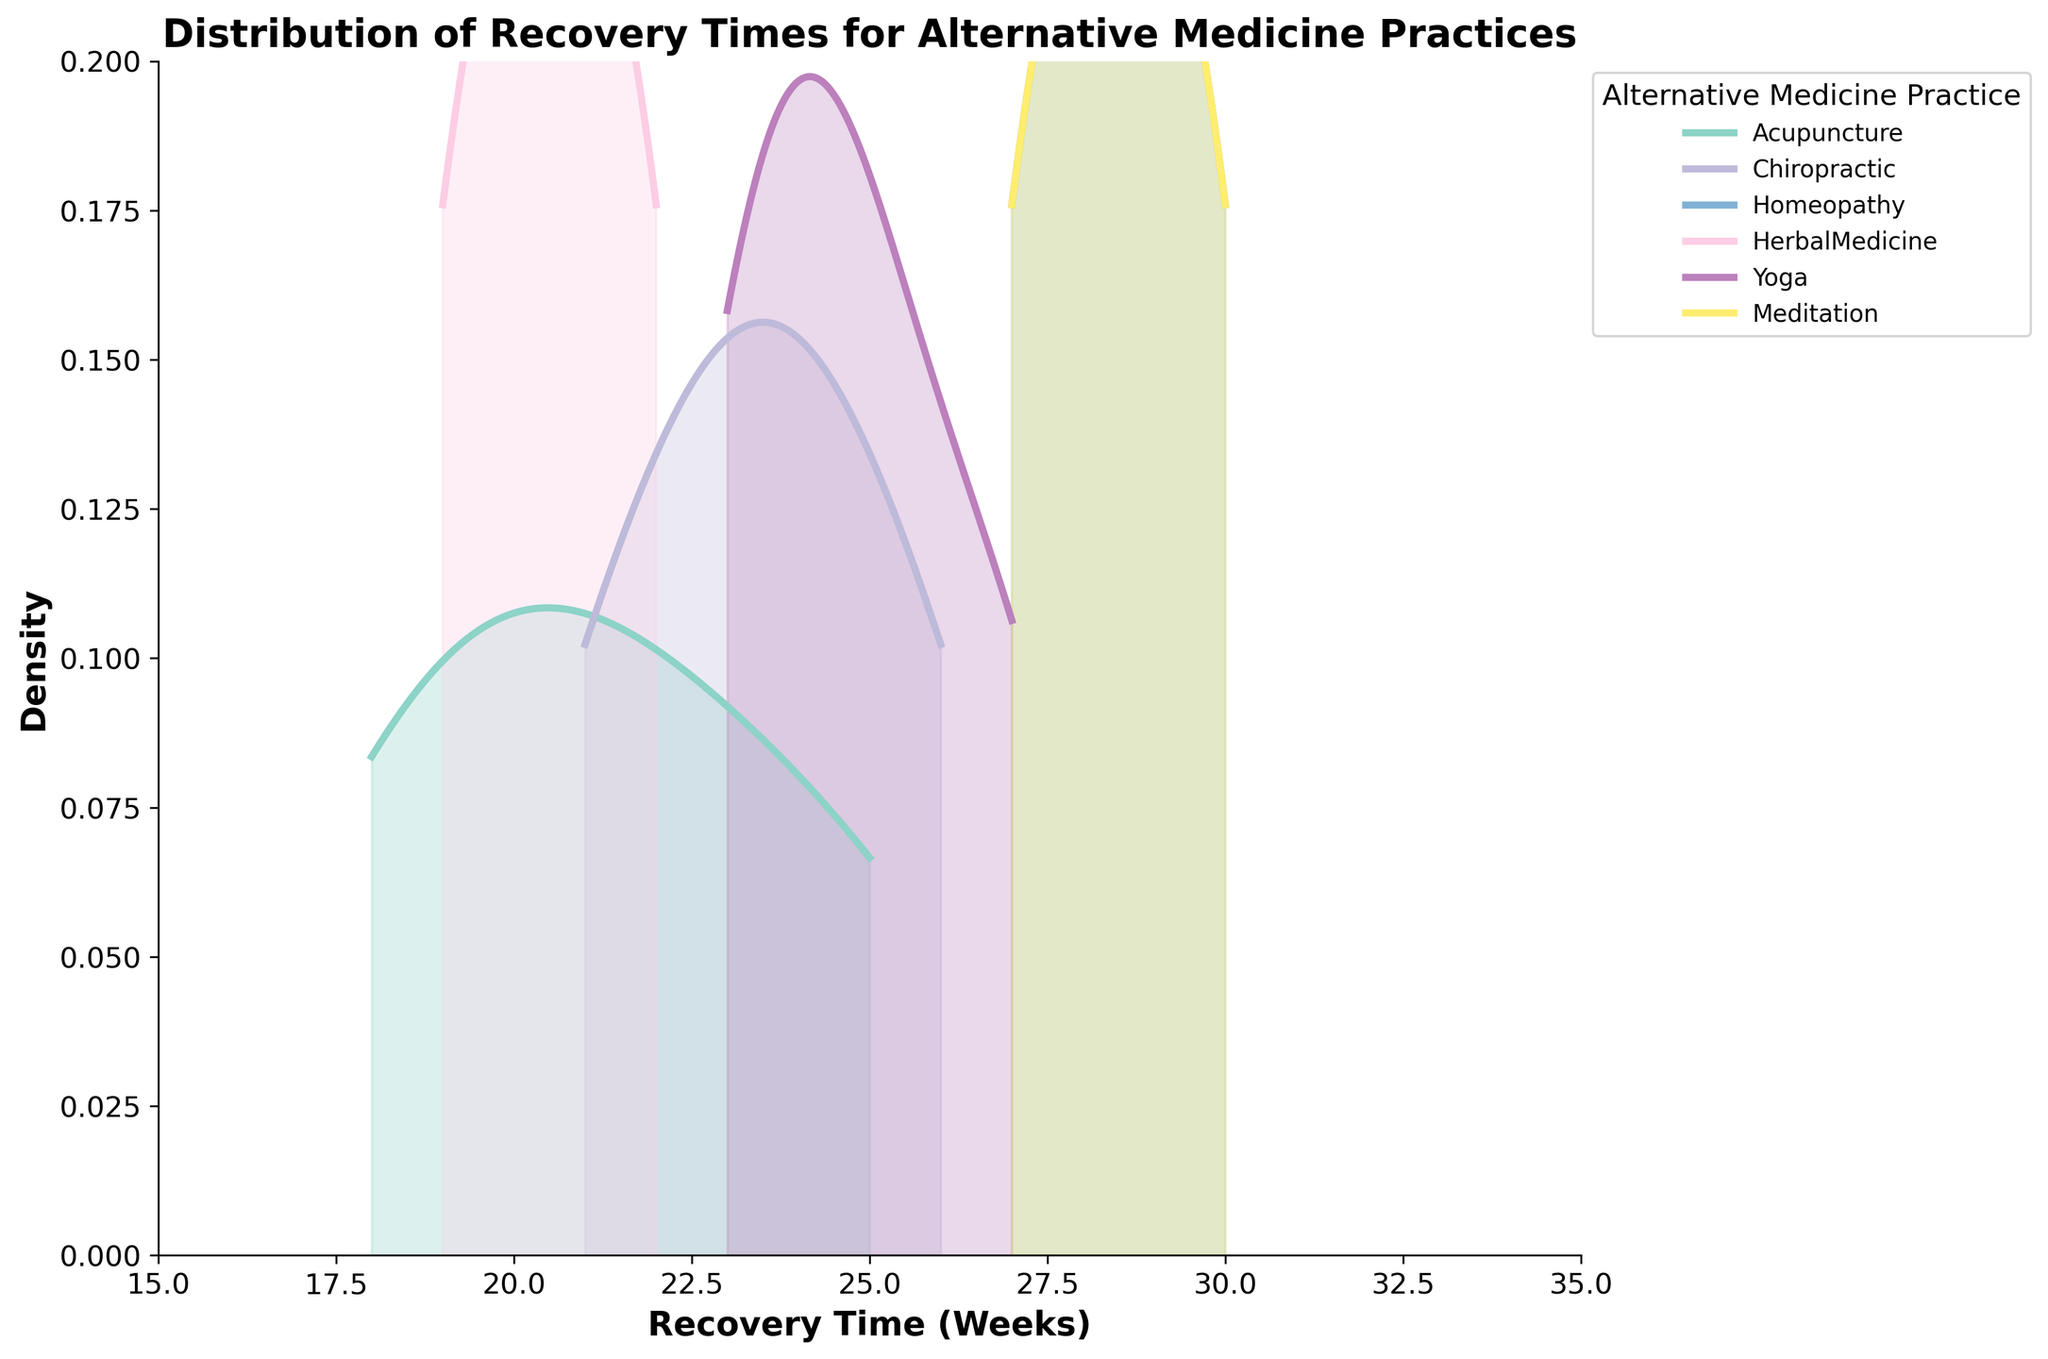What's the title of the figure? The title is usually displayed at the top of the figure. Here, it's clearly labeled to provide context about the data being visualized.
Answer: Distribution of Recovery Times for Alternative Medicine Practices What color represents Acupuncture on the plot? Each alternative medicine practice is represented by a different color, and the legend on the right indicates that Acupuncture is the color at the top.
Answer: First color listed in the legend Which alternative medicine practice has the longest average recovery time? By comparing the peaks of the density estimates (where the curves are highest), Meditation appears to have the longest average recovery time, since its peak occurs further to the right compared to others.
Answer: Meditation What is the range of recovery times covered in the plot? The x-axis shows "Recovery Time (Weeks)" and indicates the overall span of the recovery times depicted. From the plot limits, the range starts at 15 weeks and ends at 35 weeks.
Answer: 15 to 35 weeks Which alternative medicine practice has the widest spread of recovery times? By comparing the width of the density curves (how spread out they are), Homeopathy shows the widest spread as its curve covers the broadest range along the x-axis.
Answer: Homeopathy What is the peak density value for Herbal Medicine? The peak of the density curve for Herbal Medicine is observed around the highest point on its respective curve in the chart. This value can be approximated visually.
Answer: Approximately 0.16 Which practice has the most localized (narrowest) recovery time distribution? By examining the width of the density curves, Acupuncture shows a very narrow and localized distribution, indicating less variability in recovery times.
Answer: Acupuncture Compare the peak recovery times between Yoga and Chiropractic. Which is higher and by how much? The peak of Yoga's density curve is slightly higher than Chiropractic. The exact numeric value can be inferred from the x-axis (e.g., Yoga peaks around 24.5 weeks, Chiropractic around 23.5 weeks) to find the difference.
Answer: Yoga is higher by approximately 1 week How does the density curve for Herbal Medicine compare to that of Acupuncture in terms of height and spread? Herbal Medicine has a lower peak but a slightly wider spread compared to Acupuncture, as inferred from comparing the heights and widths of the respective density curves.
Answer: Lower peak, wider spread If you were looking for the shortest recovery time with minimal variation, which practice would you choose based on this figure? Based on the narrow and lower range on the x-axis, Acupuncture has the shortest and less variable recovery times among the practices.
Answer: Acupuncture 